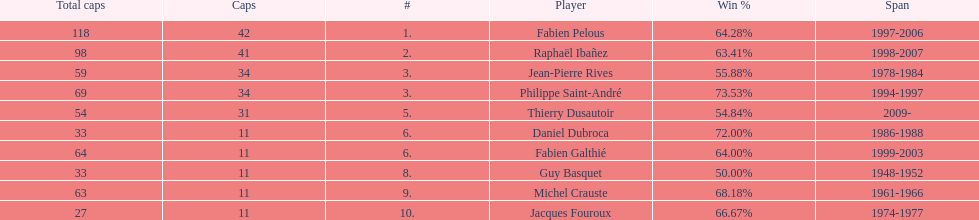How long did fabien pelous serve as captain in the french national rugby team? 9 years. 